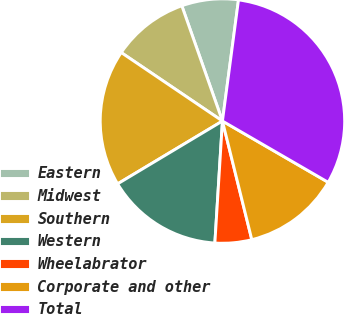<chart> <loc_0><loc_0><loc_500><loc_500><pie_chart><fcel>Eastern<fcel>Midwest<fcel>Southern<fcel>Western<fcel>Wheelabrator<fcel>Corporate and other<fcel>Total<nl><fcel>7.49%<fcel>10.14%<fcel>18.06%<fcel>15.42%<fcel>4.85%<fcel>12.78%<fcel>31.26%<nl></chart> 